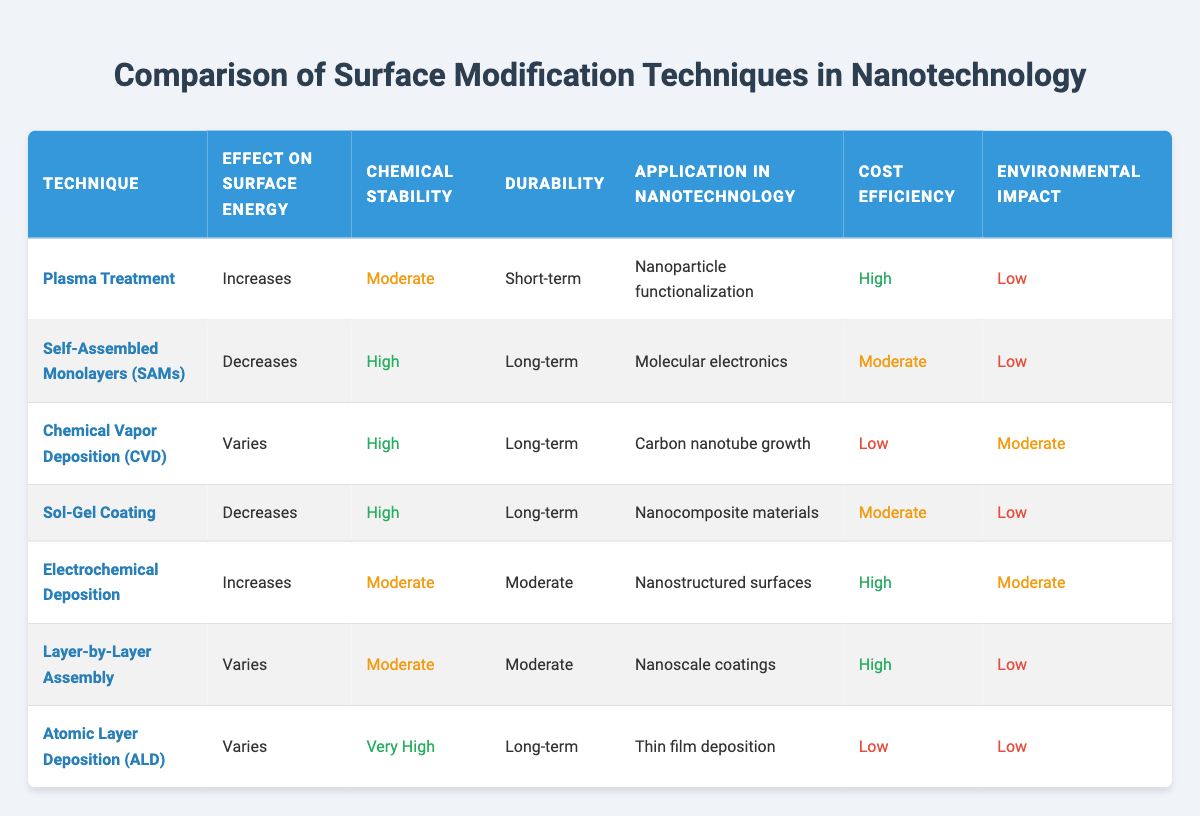What technique has the highest chemical stability? The chemical stability ratings are provided in the table. By examining the "Chemical Stability" column, we find "Very High" is associated with "Atomic Layer Deposition (ALD)".
Answer: Atomic Layer Deposition (ALD) Which surface modification technique decreases surface energy? The "Effect on Surface Energy" column shows that both "Self-Assembled Monolayers (SAMs)" and "Sol-Gel Coating" are techniques that decrease surface energy.
Answer: Self-Assembled Monolayers (SAMs) and Sol-Gel Coating How many techniques have a short-term durability? Looking at the "Durability" column, we identify "Short-term" is listed under "Plasma Treatment" only. Thus, there is only one technique with short-term durability.
Answer: 1 Is the environmental impact of "Electrochemical Deposition" low? The environmental impact rating for "Electrochemical Deposition" is marked as "Moderate" in the table, which implies it is not low.
Answer: No What is the cost efficiency classification of "Chemical Vapor Deposition (CVD)"? The "Cost Efficiency" column indicates that "Chemical Vapor Deposition (CVD)" is classified as "Low".
Answer: Low Which technique is used for nanoparticle functionalization? Referring to the "Application in Nanotechnology" column, "Plasma Treatment" is associated with "Nanoparticle functionalization".
Answer: Plasma Treatment How does the average chemical stability compare between techniques with long-term durability? Analyzing the "Chemical Stability" values of techniques with "Long-term" durability which includes "Self-Assembled Monolayers (SAMs)", "Chemical Vapor Deposition (CVD)", "Sol-Gel Coating", "Atomic Layer Deposition (ALD)", the majority are rated as "High". Only "Atomic Layer Deposition (ALD)" is rated as "Very High". Therefore, the average rating based on qualitative classification is above moderate, leaning towards high.
Answer: High Which technique has a moderate environmental impact? Looking at the "Environmental Impact" column, both "Chemical Vapor Deposition (CVD)" and "Electrochemical Deposition" are categorized as "Moderate".
Answer: Chemical Vapor Deposition (CVD) and Electrochemical Deposition How many techniques have both high chemical stability and long-term durability? By analyzing the "Chemical Stability" and "Durability" columns, we see that "Self-Assembled Monolayers (SAMs)", "Chemical Vapor Deposition (CVD)", "Sol-Gel Coating", and "Atomic Layer Deposition (ALD)" meet both criteria. Hence, there are four techniques with high chemical stability and long-term durability.
Answer: 4 